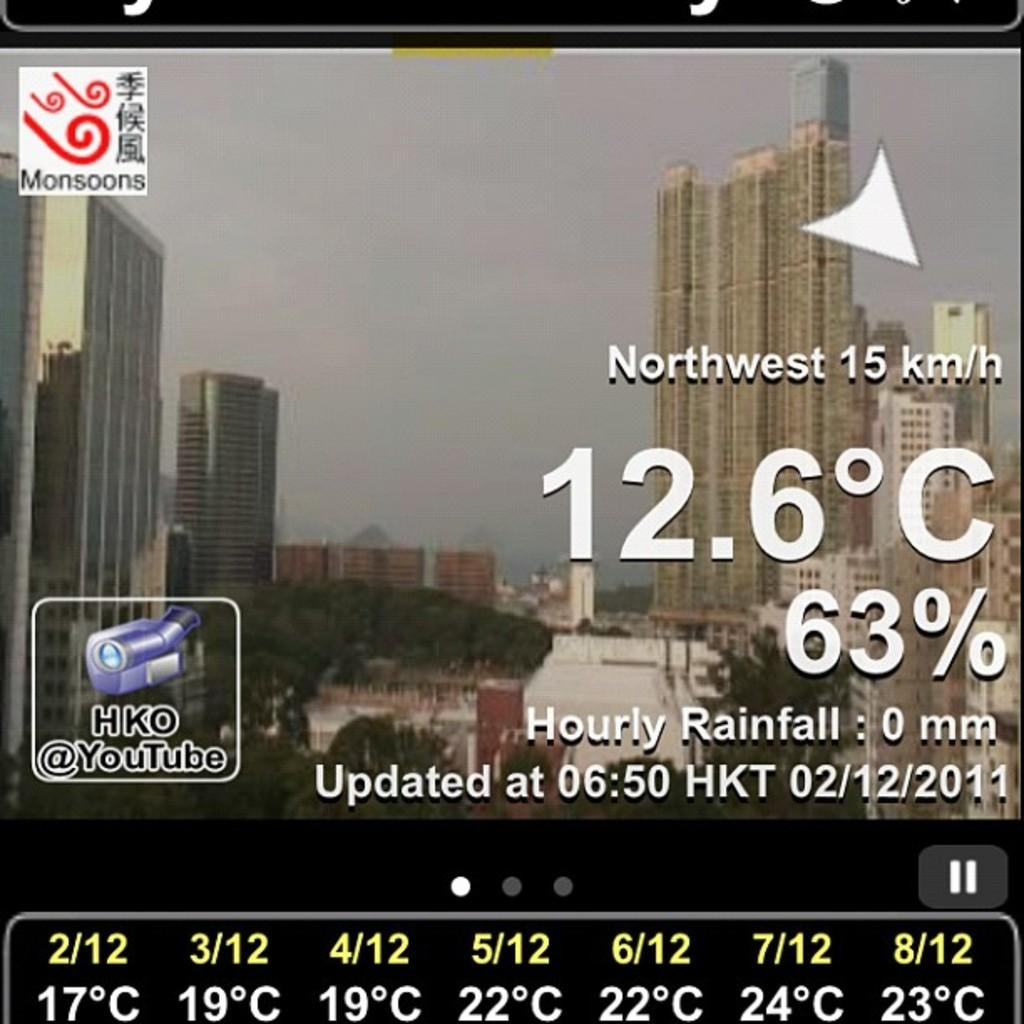What can be found in the image that contains written information? There is text in the image. What type of structures can be seen in the distance in the image? There are buildings in the background of the image. What type of natural elements are present in the background of the image? There are trees in the background of the image. Where is the logo located in the image? The logo is on the left side of the image. What is visible at the top of the image? The sky is visible at the top of the image. How does the rainstorm affect the text in the image? There is no rainstorm present in the image, so it cannot affect the text. What type of glass object is visible in the image? There is no glass object present in the image. 